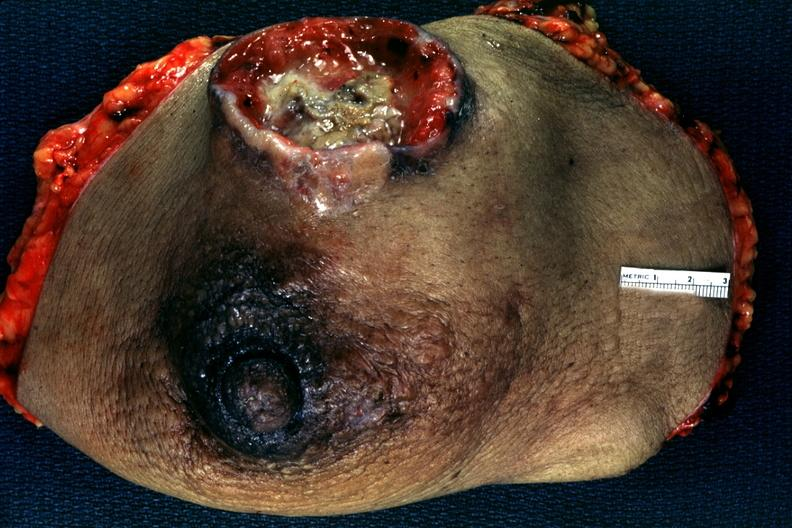what does this image show?
Answer the question using a single word or phrase. Large ulcerating carcinoma surgical specimen 